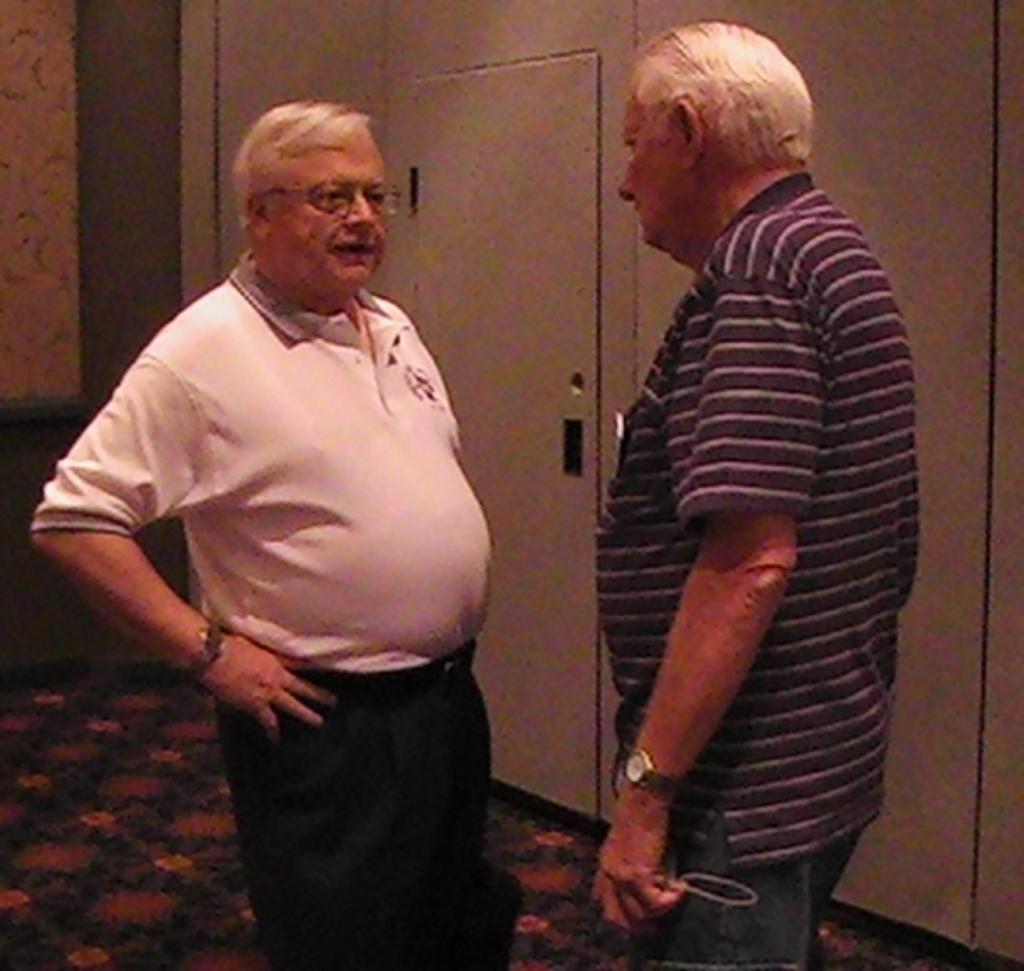In one or two sentences, can you explain what this image depicts? In this picture I can see 2 men standing in front and I see that, the man on the right is holding a thing. 